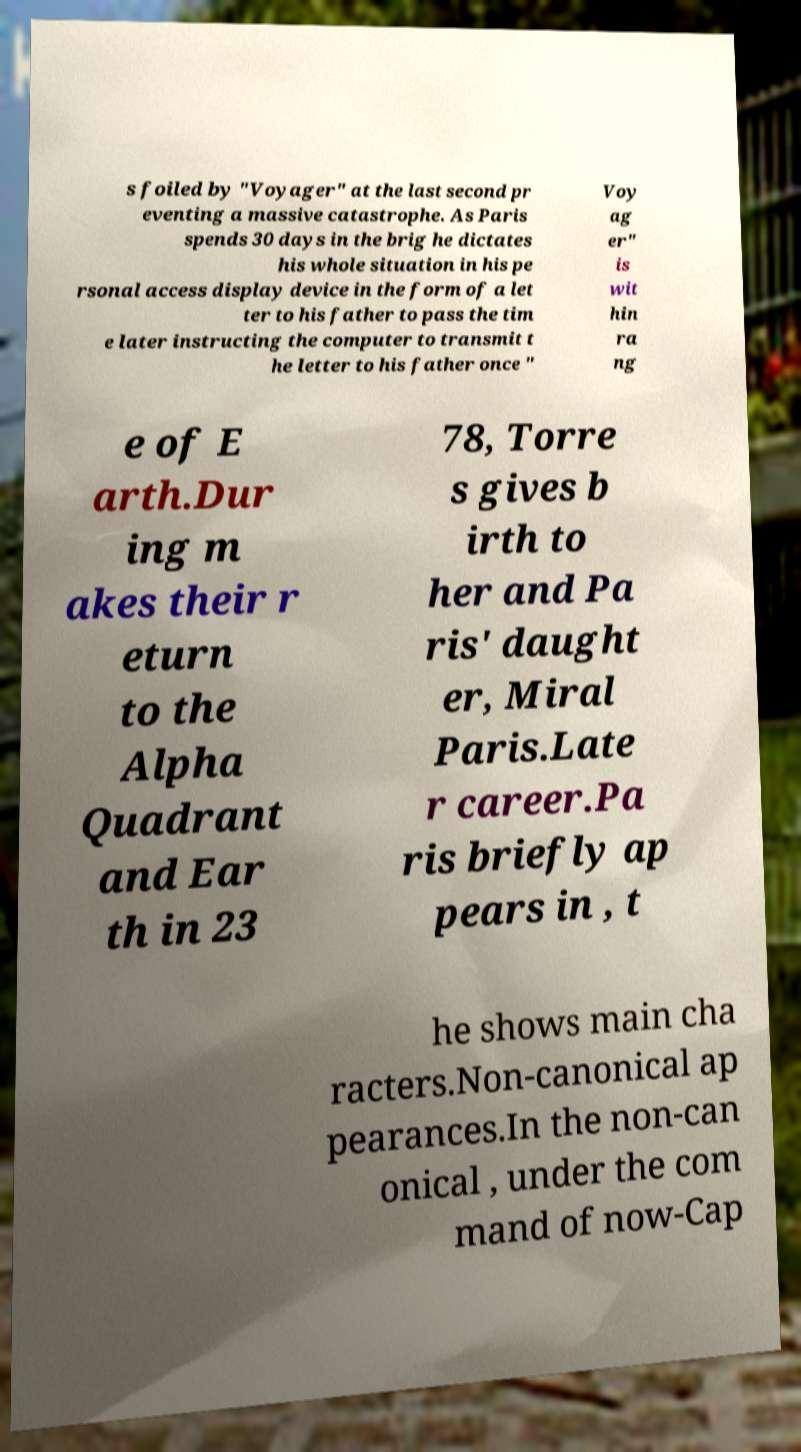For documentation purposes, I need the text within this image transcribed. Could you provide that? s foiled by "Voyager" at the last second pr eventing a massive catastrophe. As Paris spends 30 days in the brig he dictates his whole situation in his pe rsonal access display device in the form of a let ter to his father to pass the tim e later instructing the computer to transmit t he letter to his father once " Voy ag er" is wit hin ra ng e of E arth.Dur ing m akes their r eturn to the Alpha Quadrant and Ear th in 23 78, Torre s gives b irth to her and Pa ris' daught er, Miral Paris.Late r career.Pa ris briefly ap pears in , t he shows main cha racters.Non-canonical ap pearances.In the non-can onical , under the com mand of now-Cap 